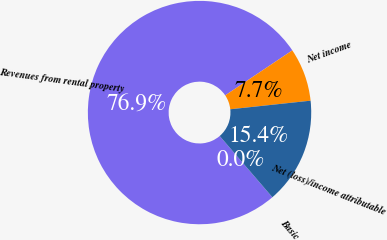<chart> <loc_0><loc_0><loc_500><loc_500><pie_chart><fcel>Revenues from rental property<fcel>Net income<fcel>Net (loss)/income attributable<fcel>Basic<nl><fcel>76.9%<fcel>7.7%<fcel>15.39%<fcel>0.01%<nl></chart> 